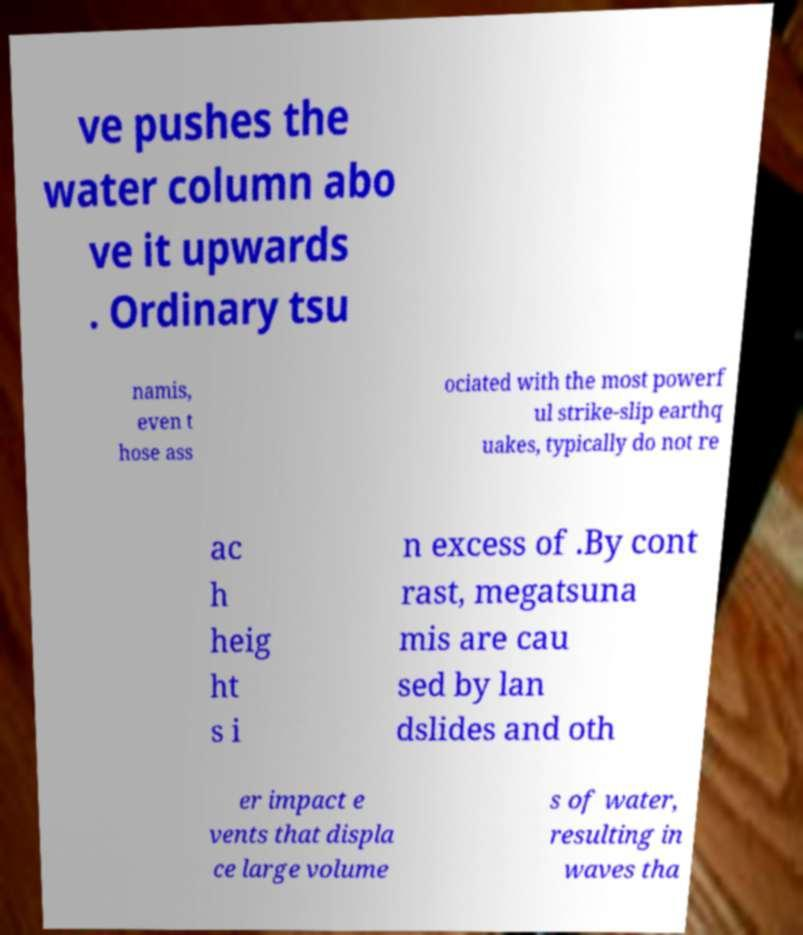For documentation purposes, I need the text within this image transcribed. Could you provide that? ve pushes the water column abo ve it upwards . Ordinary tsu namis, even t hose ass ociated with the most powerf ul strike-slip earthq uakes, typically do not re ac h heig ht s i n excess of .By cont rast, megatsuna mis are cau sed by lan dslides and oth er impact e vents that displa ce large volume s of water, resulting in waves tha 